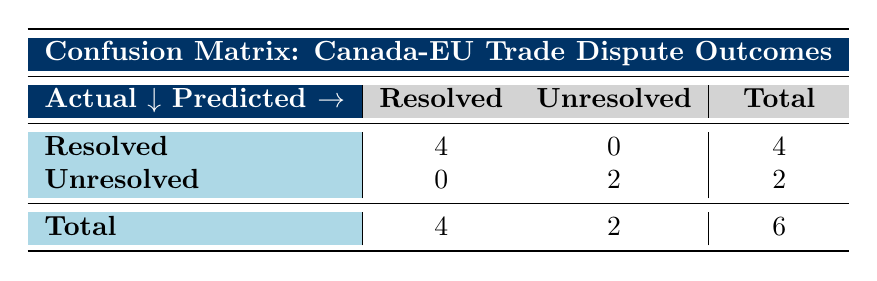What is the number of resolved cases? The table indicates that there are 4 resolved cases, as shown in the row under "Resolved" in the first column of the confusion matrix.
Answer: 4 How many cases were unresolved? The table shows that there are 2 unresolved cases located in the "Unresolved" row under the second column of the confusion matrix.
Answer: 2 What is the total number of cases? By looking at the bottom row of the confusion matrix, we see that the total number of cases is 6, which combines both resolved and unresolved cases (4 + 2).
Answer: 6 Did Canada ever lose a case against the EU? Yes, according to the table, there is one case where the outcome is "in favor of EU," indicating that Canada did not win in that instance.
Answer: Yes Is the number of resolved cases greater than or equal to the number of unresolved cases? Yes, there are 4 resolved cases and 2 unresolved cases. Since 4 is greater than 2, the statement is true.
Answer: Yes If we consider only the outcomes that were resolved, how many were settled through arbitration? From the table, out of the 4 resolved cases, only 1 case was settled via arbitration (case_id 5). Therefore, the answer is found by finding the count in the resolution column.
Answer: 1 What proportion of the total cases are in favor of Canada? In the confusion matrix, the cases in favor of Canada amount to 1; thus, dividing this by the total 6 gives a proportion of 1/6, approximately 0.17 or 17%.
Answer: 17% How many total cases were resolved by panel decisions? Reviewing the data, two cases were resolved via panel decisions: case_id 2 and case_id 3. Therefore, the answer is calculated by identifying the panel decisions in the outcomes.
Answer: 2 What is the outcome for the cases that were settled by negotiation? The data indicates there were 2 cases settled by negotiation, both resulting in a "resolved" outcome. This can be observed in case_id 1 and case_id 5.
Answer: Resolved 